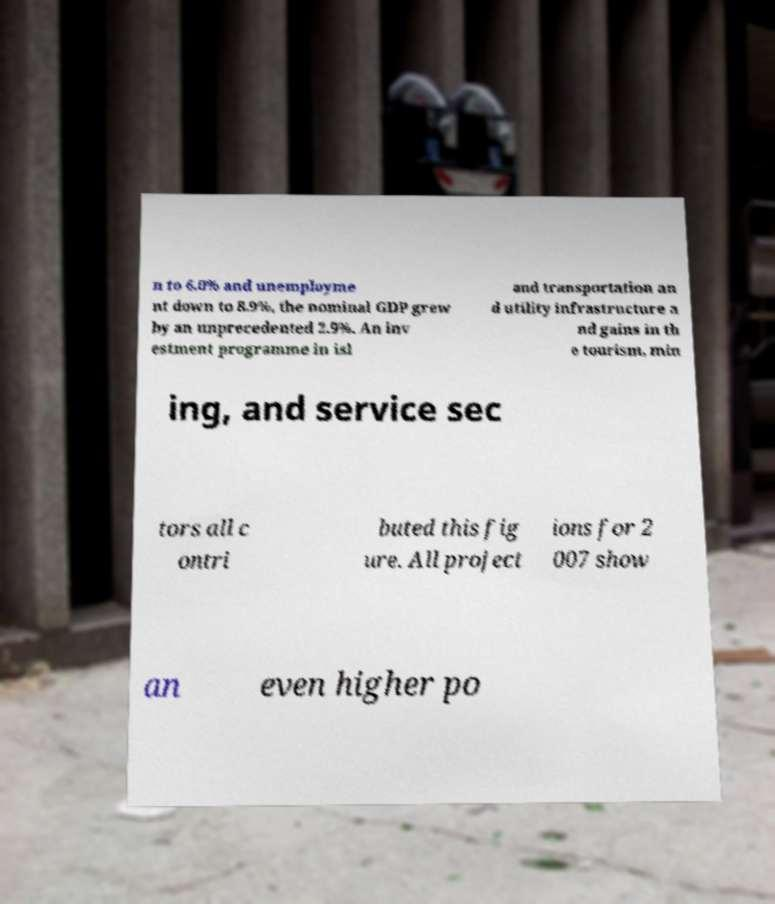There's text embedded in this image that I need extracted. Can you transcribe it verbatim? n to 6.0% and unemployme nt down to 8.9%, the nominal GDP grew by an unprecedented 2.9%. An inv estment programme in isl and transportation an d utility infrastructure a nd gains in th e tourism, min ing, and service sec tors all c ontri buted this fig ure. All project ions for 2 007 show an even higher po 